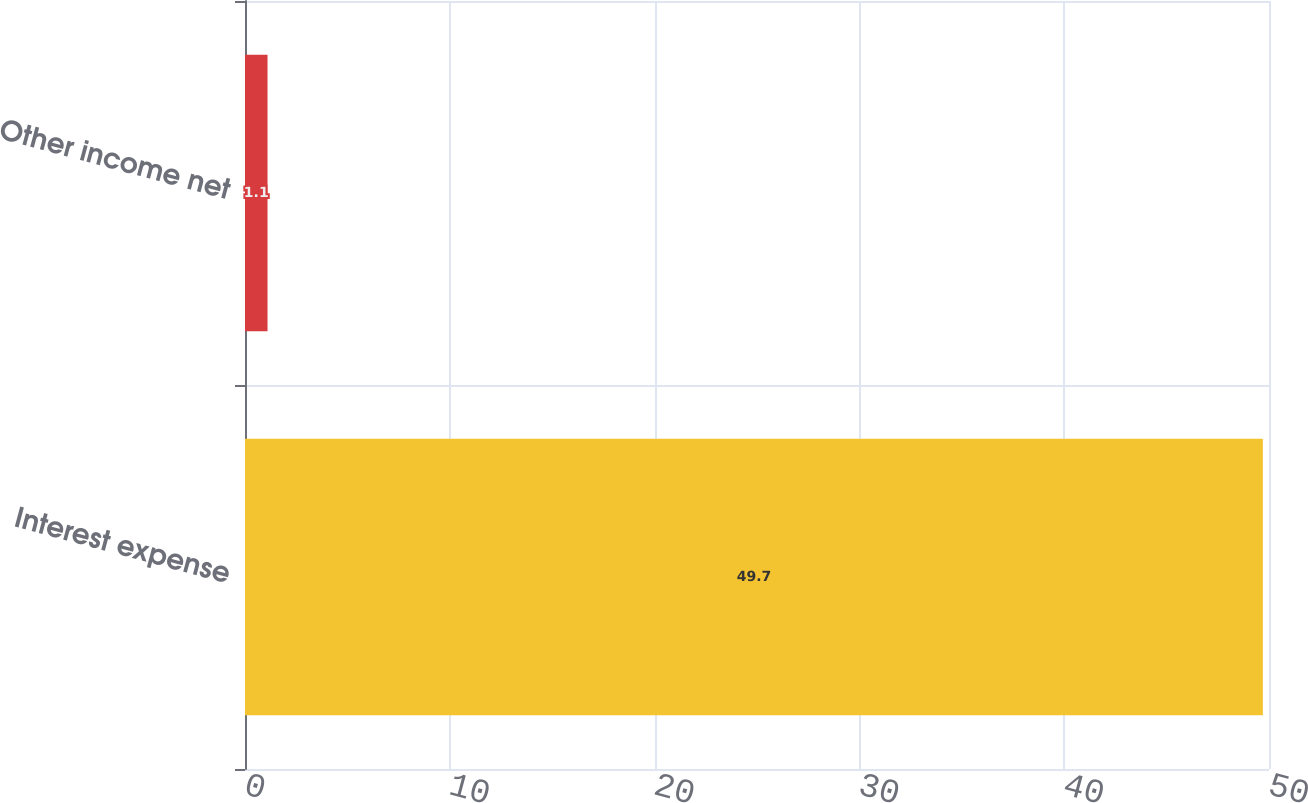Convert chart. <chart><loc_0><loc_0><loc_500><loc_500><bar_chart><fcel>Interest expense<fcel>Other income net<nl><fcel>49.7<fcel>1.1<nl></chart> 